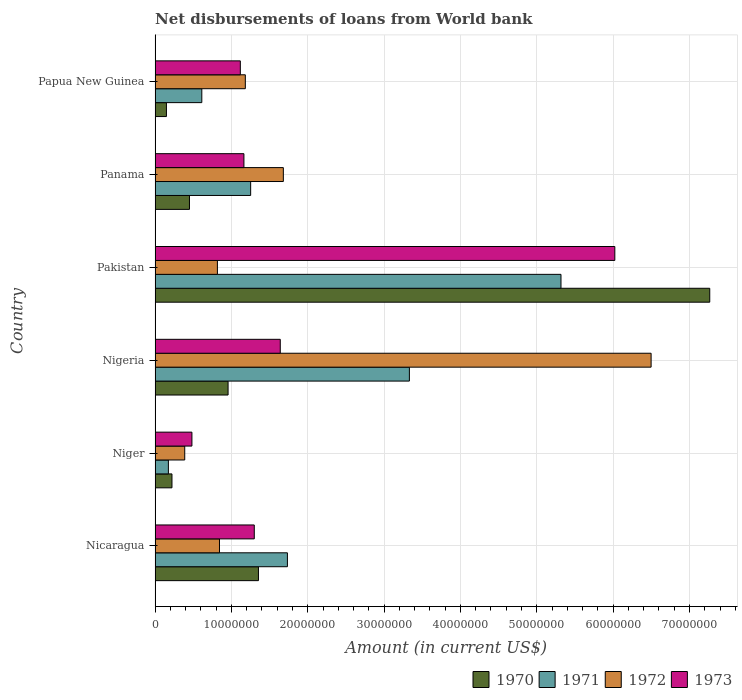How many different coloured bars are there?
Give a very brief answer. 4. How many groups of bars are there?
Provide a succinct answer. 6. Are the number of bars on each tick of the Y-axis equal?
Make the answer very short. Yes. How many bars are there on the 1st tick from the top?
Offer a terse response. 4. What is the label of the 4th group of bars from the top?
Ensure brevity in your answer.  Nigeria. What is the amount of loan disbursed from World Bank in 1972 in Niger?
Ensure brevity in your answer.  3.89e+06. Across all countries, what is the maximum amount of loan disbursed from World Bank in 1973?
Ensure brevity in your answer.  6.02e+07. Across all countries, what is the minimum amount of loan disbursed from World Bank in 1972?
Give a very brief answer. 3.89e+06. In which country was the amount of loan disbursed from World Bank in 1970 maximum?
Your response must be concise. Pakistan. In which country was the amount of loan disbursed from World Bank in 1972 minimum?
Provide a short and direct response. Niger. What is the total amount of loan disbursed from World Bank in 1970 in the graph?
Your answer should be compact. 1.04e+08. What is the difference between the amount of loan disbursed from World Bank in 1971 in Pakistan and that in Papua New Guinea?
Provide a succinct answer. 4.70e+07. What is the difference between the amount of loan disbursed from World Bank in 1971 in Papua New Guinea and the amount of loan disbursed from World Bank in 1972 in Niger?
Provide a succinct answer. 2.24e+06. What is the average amount of loan disbursed from World Bank in 1973 per country?
Your answer should be compact. 1.95e+07. What is the difference between the amount of loan disbursed from World Bank in 1970 and amount of loan disbursed from World Bank in 1971 in Nigeria?
Keep it short and to the point. -2.38e+07. What is the ratio of the amount of loan disbursed from World Bank in 1971 in Nicaragua to that in Niger?
Your response must be concise. 9.93. Is the amount of loan disbursed from World Bank in 1973 in Pakistan less than that in Papua New Guinea?
Make the answer very short. No. What is the difference between the highest and the second highest amount of loan disbursed from World Bank in 1972?
Your answer should be compact. 4.82e+07. What is the difference between the highest and the lowest amount of loan disbursed from World Bank in 1972?
Your answer should be very brief. 6.11e+07. Is the sum of the amount of loan disbursed from World Bank in 1971 in Nicaragua and Nigeria greater than the maximum amount of loan disbursed from World Bank in 1973 across all countries?
Give a very brief answer. No. What does the 2nd bar from the bottom in Nigeria represents?
Keep it short and to the point. 1971. Does the graph contain any zero values?
Give a very brief answer. No. Where does the legend appear in the graph?
Provide a short and direct response. Bottom right. How are the legend labels stacked?
Ensure brevity in your answer.  Horizontal. What is the title of the graph?
Provide a short and direct response. Net disbursements of loans from World bank. Does "1973" appear as one of the legend labels in the graph?
Provide a succinct answer. Yes. What is the label or title of the X-axis?
Give a very brief answer. Amount (in current US$). What is the label or title of the Y-axis?
Offer a terse response. Country. What is the Amount (in current US$) in 1970 in Nicaragua?
Your answer should be very brief. 1.35e+07. What is the Amount (in current US$) of 1971 in Nicaragua?
Ensure brevity in your answer.  1.73e+07. What is the Amount (in current US$) of 1972 in Nicaragua?
Keep it short and to the point. 8.44e+06. What is the Amount (in current US$) of 1973 in Nicaragua?
Offer a terse response. 1.30e+07. What is the Amount (in current US$) of 1970 in Niger?
Offer a very short reply. 2.22e+06. What is the Amount (in current US$) of 1971 in Niger?
Give a very brief answer. 1.75e+06. What is the Amount (in current US$) of 1972 in Niger?
Offer a very short reply. 3.89e+06. What is the Amount (in current US$) of 1973 in Niger?
Your response must be concise. 4.83e+06. What is the Amount (in current US$) of 1970 in Nigeria?
Ensure brevity in your answer.  9.56e+06. What is the Amount (in current US$) of 1971 in Nigeria?
Offer a very short reply. 3.33e+07. What is the Amount (in current US$) in 1972 in Nigeria?
Offer a very short reply. 6.50e+07. What is the Amount (in current US$) of 1973 in Nigeria?
Your answer should be compact. 1.64e+07. What is the Amount (in current US$) in 1970 in Pakistan?
Your answer should be very brief. 7.27e+07. What is the Amount (in current US$) in 1971 in Pakistan?
Keep it short and to the point. 5.32e+07. What is the Amount (in current US$) in 1972 in Pakistan?
Keep it short and to the point. 8.17e+06. What is the Amount (in current US$) in 1973 in Pakistan?
Make the answer very short. 6.02e+07. What is the Amount (in current US$) in 1970 in Panama?
Offer a very short reply. 4.51e+06. What is the Amount (in current US$) in 1971 in Panama?
Offer a terse response. 1.25e+07. What is the Amount (in current US$) of 1972 in Panama?
Ensure brevity in your answer.  1.68e+07. What is the Amount (in current US$) in 1973 in Panama?
Your answer should be compact. 1.16e+07. What is the Amount (in current US$) in 1970 in Papua New Guinea?
Ensure brevity in your answer.  1.49e+06. What is the Amount (in current US$) of 1971 in Papua New Guinea?
Offer a very short reply. 6.12e+06. What is the Amount (in current US$) in 1972 in Papua New Guinea?
Offer a very short reply. 1.18e+07. What is the Amount (in current US$) in 1973 in Papua New Guinea?
Your response must be concise. 1.12e+07. Across all countries, what is the maximum Amount (in current US$) of 1970?
Your response must be concise. 7.27e+07. Across all countries, what is the maximum Amount (in current US$) in 1971?
Give a very brief answer. 5.32e+07. Across all countries, what is the maximum Amount (in current US$) of 1972?
Make the answer very short. 6.50e+07. Across all countries, what is the maximum Amount (in current US$) in 1973?
Ensure brevity in your answer.  6.02e+07. Across all countries, what is the minimum Amount (in current US$) in 1970?
Give a very brief answer. 1.49e+06. Across all countries, what is the minimum Amount (in current US$) in 1971?
Offer a very short reply. 1.75e+06. Across all countries, what is the minimum Amount (in current US$) of 1972?
Make the answer very short. 3.89e+06. Across all countries, what is the minimum Amount (in current US$) of 1973?
Make the answer very short. 4.83e+06. What is the total Amount (in current US$) in 1970 in the graph?
Ensure brevity in your answer.  1.04e+08. What is the total Amount (in current US$) of 1971 in the graph?
Your response must be concise. 1.24e+08. What is the total Amount (in current US$) in 1972 in the graph?
Provide a short and direct response. 1.14e+08. What is the total Amount (in current US$) of 1973 in the graph?
Make the answer very short. 1.17e+08. What is the difference between the Amount (in current US$) in 1970 in Nicaragua and that in Niger?
Keep it short and to the point. 1.13e+07. What is the difference between the Amount (in current US$) in 1971 in Nicaragua and that in Niger?
Ensure brevity in your answer.  1.56e+07. What is the difference between the Amount (in current US$) in 1972 in Nicaragua and that in Niger?
Give a very brief answer. 4.55e+06. What is the difference between the Amount (in current US$) in 1973 in Nicaragua and that in Niger?
Provide a succinct answer. 8.17e+06. What is the difference between the Amount (in current US$) in 1970 in Nicaragua and that in Nigeria?
Your response must be concise. 3.98e+06. What is the difference between the Amount (in current US$) in 1971 in Nicaragua and that in Nigeria?
Provide a succinct answer. -1.60e+07. What is the difference between the Amount (in current US$) of 1972 in Nicaragua and that in Nigeria?
Keep it short and to the point. -5.65e+07. What is the difference between the Amount (in current US$) of 1973 in Nicaragua and that in Nigeria?
Offer a very short reply. -3.40e+06. What is the difference between the Amount (in current US$) in 1970 in Nicaragua and that in Pakistan?
Your answer should be compact. -5.91e+07. What is the difference between the Amount (in current US$) of 1971 in Nicaragua and that in Pakistan?
Ensure brevity in your answer.  -3.58e+07. What is the difference between the Amount (in current US$) of 1972 in Nicaragua and that in Pakistan?
Give a very brief answer. 2.72e+05. What is the difference between the Amount (in current US$) of 1973 in Nicaragua and that in Pakistan?
Provide a short and direct response. -4.72e+07. What is the difference between the Amount (in current US$) in 1970 in Nicaragua and that in Panama?
Your answer should be very brief. 9.03e+06. What is the difference between the Amount (in current US$) in 1971 in Nicaragua and that in Panama?
Offer a terse response. 4.82e+06. What is the difference between the Amount (in current US$) in 1972 in Nicaragua and that in Panama?
Offer a very short reply. -8.37e+06. What is the difference between the Amount (in current US$) in 1973 in Nicaragua and that in Panama?
Give a very brief answer. 1.36e+06. What is the difference between the Amount (in current US$) of 1970 in Nicaragua and that in Papua New Guinea?
Provide a succinct answer. 1.21e+07. What is the difference between the Amount (in current US$) of 1971 in Nicaragua and that in Papua New Guinea?
Your response must be concise. 1.12e+07. What is the difference between the Amount (in current US$) of 1972 in Nicaragua and that in Papua New Guinea?
Make the answer very short. -3.38e+06. What is the difference between the Amount (in current US$) of 1973 in Nicaragua and that in Papua New Guinea?
Your answer should be very brief. 1.83e+06. What is the difference between the Amount (in current US$) of 1970 in Niger and that in Nigeria?
Provide a succinct answer. -7.35e+06. What is the difference between the Amount (in current US$) of 1971 in Niger and that in Nigeria?
Your response must be concise. -3.16e+07. What is the difference between the Amount (in current US$) of 1972 in Niger and that in Nigeria?
Your answer should be very brief. -6.11e+07. What is the difference between the Amount (in current US$) in 1973 in Niger and that in Nigeria?
Offer a terse response. -1.16e+07. What is the difference between the Amount (in current US$) of 1970 in Niger and that in Pakistan?
Offer a terse response. -7.04e+07. What is the difference between the Amount (in current US$) of 1971 in Niger and that in Pakistan?
Offer a very short reply. -5.14e+07. What is the difference between the Amount (in current US$) in 1972 in Niger and that in Pakistan?
Your answer should be compact. -4.28e+06. What is the difference between the Amount (in current US$) of 1973 in Niger and that in Pakistan?
Your answer should be compact. -5.54e+07. What is the difference between the Amount (in current US$) of 1970 in Niger and that in Panama?
Your response must be concise. -2.29e+06. What is the difference between the Amount (in current US$) in 1971 in Niger and that in Panama?
Your answer should be compact. -1.08e+07. What is the difference between the Amount (in current US$) in 1972 in Niger and that in Panama?
Make the answer very short. -1.29e+07. What is the difference between the Amount (in current US$) of 1973 in Niger and that in Panama?
Provide a succinct answer. -6.81e+06. What is the difference between the Amount (in current US$) in 1970 in Niger and that in Papua New Guinea?
Provide a short and direct response. 7.25e+05. What is the difference between the Amount (in current US$) of 1971 in Niger and that in Papua New Guinea?
Keep it short and to the point. -4.38e+06. What is the difference between the Amount (in current US$) in 1972 in Niger and that in Papua New Guinea?
Ensure brevity in your answer.  -7.94e+06. What is the difference between the Amount (in current US$) in 1973 in Niger and that in Papua New Guinea?
Offer a terse response. -6.34e+06. What is the difference between the Amount (in current US$) of 1970 in Nigeria and that in Pakistan?
Your response must be concise. -6.31e+07. What is the difference between the Amount (in current US$) in 1971 in Nigeria and that in Pakistan?
Provide a succinct answer. -1.99e+07. What is the difference between the Amount (in current US$) in 1972 in Nigeria and that in Pakistan?
Offer a very short reply. 5.68e+07. What is the difference between the Amount (in current US$) of 1973 in Nigeria and that in Pakistan?
Your answer should be very brief. -4.38e+07. What is the difference between the Amount (in current US$) of 1970 in Nigeria and that in Panama?
Offer a very short reply. 5.06e+06. What is the difference between the Amount (in current US$) in 1971 in Nigeria and that in Panama?
Provide a succinct answer. 2.08e+07. What is the difference between the Amount (in current US$) in 1972 in Nigeria and that in Panama?
Provide a succinct answer. 4.82e+07. What is the difference between the Amount (in current US$) in 1973 in Nigeria and that in Panama?
Your answer should be compact. 4.76e+06. What is the difference between the Amount (in current US$) in 1970 in Nigeria and that in Papua New Guinea?
Offer a terse response. 8.07e+06. What is the difference between the Amount (in current US$) in 1971 in Nigeria and that in Papua New Guinea?
Keep it short and to the point. 2.72e+07. What is the difference between the Amount (in current US$) in 1972 in Nigeria and that in Papua New Guinea?
Make the answer very short. 5.32e+07. What is the difference between the Amount (in current US$) in 1973 in Nigeria and that in Papua New Guinea?
Give a very brief answer. 5.23e+06. What is the difference between the Amount (in current US$) of 1970 in Pakistan and that in Panama?
Provide a short and direct response. 6.81e+07. What is the difference between the Amount (in current US$) of 1971 in Pakistan and that in Panama?
Offer a terse response. 4.06e+07. What is the difference between the Amount (in current US$) in 1972 in Pakistan and that in Panama?
Provide a succinct answer. -8.64e+06. What is the difference between the Amount (in current US$) in 1973 in Pakistan and that in Panama?
Offer a terse response. 4.86e+07. What is the difference between the Amount (in current US$) of 1970 in Pakistan and that in Papua New Guinea?
Provide a short and direct response. 7.12e+07. What is the difference between the Amount (in current US$) of 1971 in Pakistan and that in Papua New Guinea?
Ensure brevity in your answer.  4.70e+07. What is the difference between the Amount (in current US$) in 1972 in Pakistan and that in Papua New Guinea?
Offer a very short reply. -3.66e+06. What is the difference between the Amount (in current US$) of 1973 in Pakistan and that in Papua New Guinea?
Your answer should be compact. 4.91e+07. What is the difference between the Amount (in current US$) of 1970 in Panama and that in Papua New Guinea?
Your response must be concise. 3.02e+06. What is the difference between the Amount (in current US$) of 1971 in Panama and that in Papua New Guinea?
Provide a short and direct response. 6.40e+06. What is the difference between the Amount (in current US$) in 1972 in Panama and that in Papua New Guinea?
Provide a succinct answer. 4.98e+06. What is the difference between the Amount (in current US$) of 1973 in Panama and that in Papua New Guinea?
Ensure brevity in your answer.  4.71e+05. What is the difference between the Amount (in current US$) in 1970 in Nicaragua and the Amount (in current US$) in 1971 in Niger?
Ensure brevity in your answer.  1.18e+07. What is the difference between the Amount (in current US$) in 1970 in Nicaragua and the Amount (in current US$) in 1972 in Niger?
Give a very brief answer. 9.66e+06. What is the difference between the Amount (in current US$) in 1970 in Nicaragua and the Amount (in current US$) in 1973 in Niger?
Ensure brevity in your answer.  8.71e+06. What is the difference between the Amount (in current US$) of 1971 in Nicaragua and the Amount (in current US$) of 1972 in Niger?
Your answer should be very brief. 1.35e+07. What is the difference between the Amount (in current US$) of 1971 in Nicaragua and the Amount (in current US$) of 1973 in Niger?
Your answer should be very brief. 1.25e+07. What is the difference between the Amount (in current US$) in 1972 in Nicaragua and the Amount (in current US$) in 1973 in Niger?
Your answer should be very brief. 3.61e+06. What is the difference between the Amount (in current US$) of 1970 in Nicaragua and the Amount (in current US$) of 1971 in Nigeria?
Your answer should be very brief. -1.98e+07. What is the difference between the Amount (in current US$) in 1970 in Nicaragua and the Amount (in current US$) in 1972 in Nigeria?
Offer a very short reply. -5.14e+07. What is the difference between the Amount (in current US$) of 1970 in Nicaragua and the Amount (in current US$) of 1973 in Nigeria?
Ensure brevity in your answer.  -2.86e+06. What is the difference between the Amount (in current US$) of 1971 in Nicaragua and the Amount (in current US$) of 1972 in Nigeria?
Provide a succinct answer. -4.76e+07. What is the difference between the Amount (in current US$) in 1971 in Nicaragua and the Amount (in current US$) in 1973 in Nigeria?
Offer a terse response. 9.37e+05. What is the difference between the Amount (in current US$) of 1972 in Nicaragua and the Amount (in current US$) of 1973 in Nigeria?
Your answer should be very brief. -7.96e+06. What is the difference between the Amount (in current US$) of 1970 in Nicaragua and the Amount (in current US$) of 1971 in Pakistan?
Provide a succinct answer. -3.96e+07. What is the difference between the Amount (in current US$) in 1970 in Nicaragua and the Amount (in current US$) in 1972 in Pakistan?
Provide a succinct answer. 5.38e+06. What is the difference between the Amount (in current US$) of 1970 in Nicaragua and the Amount (in current US$) of 1973 in Pakistan?
Keep it short and to the point. -4.67e+07. What is the difference between the Amount (in current US$) in 1971 in Nicaragua and the Amount (in current US$) in 1972 in Pakistan?
Keep it short and to the point. 9.17e+06. What is the difference between the Amount (in current US$) of 1971 in Nicaragua and the Amount (in current US$) of 1973 in Pakistan?
Your response must be concise. -4.29e+07. What is the difference between the Amount (in current US$) in 1972 in Nicaragua and the Amount (in current US$) in 1973 in Pakistan?
Keep it short and to the point. -5.18e+07. What is the difference between the Amount (in current US$) of 1970 in Nicaragua and the Amount (in current US$) of 1971 in Panama?
Offer a terse response. 1.02e+06. What is the difference between the Amount (in current US$) in 1970 in Nicaragua and the Amount (in current US$) in 1972 in Panama?
Make the answer very short. -3.26e+06. What is the difference between the Amount (in current US$) in 1970 in Nicaragua and the Amount (in current US$) in 1973 in Panama?
Make the answer very short. 1.90e+06. What is the difference between the Amount (in current US$) in 1971 in Nicaragua and the Amount (in current US$) in 1972 in Panama?
Give a very brief answer. 5.33e+05. What is the difference between the Amount (in current US$) in 1971 in Nicaragua and the Amount (in current US$) in 1973 in Panama?
Keep it short and to the point. 5.70e+06. What is the difference between the Amount (in current US$) of 1972 in Nicaragua and the Amount (in current US$) of 1973 in Panama?
Offer a terse response. -3.20e+06. What is the difference between the Amount (in current US$) of 1970 in Nicaragua and the Amount (in current US$) of 1971 in Papua New Guinea?
Keep it short and to the point. 7.42e+06. What is the difference between the Amount (in current US$) in 1970 in Nicaragua and the Amount (in current US$) in 1972 in Papua New Guinea?
Your answer should be very brief. 1.72e+06. What is the difference between the Amount (in current US$) of 1970 in Nicaragua and the Amount (in current US$) of 1973 in Papua New Guinea?
Your answer should be very brief. 2.37e+06. What is the difference between the Amount (in current US$) in 1971 in Nicaragua and the Amount (in current US$) in 1972 in Papua New Guinea?
Ensure brevity in your answer.  5.51e+06. What is the difference between the Amount (in current US$) of 1971 in Nicaragua and the Amount (in current US$) of 1973 in Papua New Guinea?
Offer a terse response. 6.17e+06. What is the difference between the Amount (in current US$) in 1972 in Nicaragua and the Amount (in current US$) in 1973 in Papua New Guinea?
Your answer should be compact. -2.73e+06. What is the difference between the Amount (in current US$) of 1970 in Niger and the Amount (in current US$) of 1971 in Nigeria?
Offer a terse response. -3.11e+07. What is the difference between the Amount (in current US$) in 1970 in Niger and the Amount (in current US$) in 1972 in Nigeria?
Offer a very short reply. -6.28e+07. What is the difference between the Amount (in current US$) in 1970 in Niger and the Amount (in current US$) in 1973 in Nigeria?
Offer a terse response. -1.42e+07. What is the difference between the Amount (in current US$) of 1971 in Niger and the Amount (in current US$) of 1972 in Nigeria?
Provide a short and direct response. -6.32e+07. What is the difference between the Amount (in current US$) of 1971 in Niger and the Amount (in current US$) of 1973 in Nigeria?
Give a very brief answer. -1.47e+07. What is the difference between the Amount (in current US$) in 1972 in Niger and the Amount (in current US$) in 1973 in Nigeria?
Your answer should be very brief. -1.25e+07. What is the difference between the Amount (in current US$) in 1970 in Niger and the Amount (in current US$) in 1971 in Pakistan?
Provide a succinct answer. -5.10e+07. What is the difference between the Amount (in current US$) of 1970 in Niger and the Amount (in current US$) of 1972 in Pakistan?
Give a very brief answer. -5.95e+06. What is the difference between the Amount (in current US$) of 1970 in Niger and the Amount (in current US$) of 1973 in Pakistan?
Give a very brief answer. -5.80e+07. What is the difference between the Amount (in current US$) in 1971 in Niger and the Amount (in current US$) in 1972 in Pakistan?
Your response must be concise. -6.42e+06. What is the difference between the Amount (in current US$) in 1971 in Niger and the Amount (in current US$) in 1973 in Pakistan?
Your response must be concise. -5.85e+07. What is the difference between the Amount (in current US$) of 1972 in Niger and the Amount (in current US$) of 1973 in Pakistan?
Offer a terse response. -5.63e+07. What is the difference between the Amount (in current US$) of 1970 in Niger and the Amount (in current US$) of 1971 in Panama?
Provide a short and direct response. -1.03e+07. What is the difference between the Amount (in current US$) in 1970 in Niger and the Amount (in current US$) in 1972 in Panama?
Your answer should be very brief. -1.46e+07. What is the difference between the Amount (in current US$) of 1970 in Niger and the Amount (in current US$) of 1973 in Panama?
Give a very brief answer. -9.42e+06. What is the difference between the Amount (in current US$) of 1971 in Niger and the Amount (in current US$) of 1972 in Panama?
Provide a short and direct response. -1.51e+07. What is the difference between the Amount (in current US$) of 1971 in Niger and the Amount (in current US$) of 1973 in Panama?
Provide a short and direct response. -9.89e+06. What is the difference between the Amount (in current US$) of 1972 in Niger and the Amount (in current US$) of 1973 in Panama?
Your answer should be compact. -7.75e+06. What is the difference between the Amount (in current US$) in 1970 in Niger and the Amount (in current US$) in 1971 in Papua New Guinea?
Offer a terse response. -3.91e+06. What is the difference between the Amount (in current US$) of 1970 in Niger and the Amount (in current US$) of 1972 in Papua New Guinea?
Provide a succinct answer. -9.61e+06. What is the difference between the Amount (in current US$) in 1970 in Niger and the Amount (in current US$) in 1973 in Papua New Guinea?
Your answer should be very brief. -8.95e+06. What is the difference between the Amount (in current US$) of 1971 in Niger and the Amount (in current US$) of 1972 in Papua New Guinea?
Your answer should be compact. -1.01e+07. What is the difference between the Amount (in current US$) in 1971 in Niger and the Amount (in current US$) in 1973 in Papua New Guinea?
Ensure brevity in your answer.  -9.42e+06. What is the difference between the Amount (in current US$) of 1972 in Niger and the Amount (in current US$) of 1973 in Papua New Guinea?
Provide a short and direct response. -7.28e+06. What is the difference between the Amount (in current US$) in 1970 in Nigeria and the Amount (in current US$) in 1971 in Pakistan?
Give a very brief answer. -4.36e+07. What is the difference between the Amount (in current US$) in 1970 in Nigeria and the Amount (in current US$) in 1972 in Pakistan?
Provide a short and direct response. 1.40e+06. What is the difference between the Amount (in current US$) of 1970 in Nigeria and the Amount (in current US$) of 1973 in Pakistan?
Your answer should be very brief. -5.07e+07. What is the difference between the Amount (in current US$) in 1971 in Nigeria and the Amount (in current US$) in 1972 in Pakistan?
Keep it short and to the point. 2.51e+07. What is the difference between the Amount (in current US$) in 1971 in Nigeria and the Amount (in current US$) in 1973 in Pakistan?
Your response must be concise. -2.69e+07. What is the difference between the Amount (in current US$) of 1972 in Nigeria and the Amount (in current US$) of 1973 in Pakistan?
Make the answer very short. 4.75e+06. What is the difference between the Amount (in current US$) in 1970 in Nigeria and the Amount (in current US$) in 1971 in Panama?
Offer a terse response. -2.96e+06. What is the difference between the Amount (in current US$) in 1970 in Nigeria and the Amount (in current US$) in 1972 in Panama?
Keep it short and to the point. -7.24e+06. What is the difference between the Amount (in current US$) of 1970 in Nigeria and the Amount (in current US$) of 1973 in Panama?
Ensure brevity in your answer.  -2.08e+06. What is the difference between the Amount (in current US$) of 1971 in Nigeria and the Amount (in current US$) of 1972 in Panama?
Ensure brevity in your answer.  1.65e+07. What is the difference between the Amount (in current US$) in 1971 in Nigeria and the Amount (in current US$) in 1973 in Panama?
Keep it short and to the point. 2.17e+07. What is the difference between the Amount (in current US$) in 1972 in Nigeria and the Amount (in current US$) in 1973 in Panama?
Your answer should be very brief. 5.33e+07. What is the difference between the Amount (in current US$) of 1970 in Nigeria and the Amount (in current US$) of 1971 in Papua New Guinea?
Offer a very short reply. 3.44e+06. What is the difference between the Amount (in current US$) in 1970 in Nigeria and the Amount (in current US$) in 1972 in Papua New Guinea?
Provide a succinct answer. -2.26e+06. What is the difference between the Amount (in current US$) in 1970 in Nigeria and the Amount (in current US$) in 1973 in Papua New Guinea?
Your answer should be very brief. -1.60e+06. What is the difference between the Amount (in current US$) of 1971 in Nigeria and the Amount (in current US$) of 1972 in Papua New Guinea?
Give a very brief answer. 2.15e+07. What is the difference between the Amount (in current US$) of 1971 in Nigeria and the Amount (in current US$) of 1973 in Papua New Guinea?
Your response must be concise. 2.21e+07. What is the difference between the Amount (in current US$) in 1972 in Nigeria and the Amount (in current US$) in 1973 in Papua New Guinea?
Give a very brief answer. 5.38e+07. What is the difference between the Amount (in current US$) in 1970 in Pakistan and the Amount (in current US$) in 1971 in Panama?
Your answer should be very brief. 6.01e+07. What is the difference between the Amount (in current US$) in 1970 in Pakistan and the Amount (in current US$) in 1972 in Panama?
Offer a terse response. 5.59e+07. What is the difference between the Amount (in current US$) of 1970 in Pakistan and the Amount (in current US$) of 1973 in Panama?
Your answer should be compact. 6.10e+07. What is the difference between the Amount (in current US$) of 1971 in Pakistan and the Amount (in current US$) of 1972 in Panama?
Make the answer very short. 3.64e+07. What is the difference between the Amount (in current US$) of 1971 in Pakistan and the Amount (in current US$) of 1973 in Panama?
Your answer should be compact. 4.15e+07. What is the difference between the Amount (in current US$) of 1972 in Pakistan and the Amount (in current US$) of 1973 in Panama?
Offer a very short reply. -3.47e+06. What is the difference between the Amount (in current US$) of 1970 in Pakistan and the Amount (in current US$) of 1971 in Papua New Guinea?
Your answer should be compact. 6.65e+07. What is the difference between the Amount (in current US$) of 1970 in Pakistan and the Amount (in current US$) of 1972 in Papua New Guinea?
Provide a short and direct response. 6.08e+07. What is the difference between the Amount (in current US$) of 1970 in Pakistan and the Amount (in current US$) of 1973 in Papua New Guinea?
Your answer should be very brief. 6.15e+07. What is the difference between the Amount (in current US$) of 1971 in Pakistan and the Amount (in current US$) of 1972 in Papua New Guinea?
Make the answer very short. 4.13e+07. What is the difference between the Amount (in current US$) in 1971 in Pakistan and the Amount (in current US$) in 1973 in Papua New Guinea?
Provide a short and direct response. 4.20e+07. What is the difference between the Amount (in current US$) of 1972 in Pakistan and the Amount (in current US$) of 1973 in Papua New Guinea?
Provide a short and direct response. -3.00e+06. What is the difference between the Amount (in current US$) of 1970 in Panama and the Amount (in current US$) of 1971 in Papua New Guinea?
Offer a terse response. -1.62e+06. What is the difference between the Amount (in current US$) in 1970 in Panama and the Amount (in current US$) in 1972 in Papua New Guinea?
Your answer should be compact. -7.32e+06. What is the difference between the Amount (in current US$) in 1970 in Panama and the Amount (in current US$) in 1973 in Papua New Guinea?
Provide a succinct answer. -6.66e+06. What is the difference between the Amount (in current US$) in 1971 in Panama and the Amount (in current US$) in 1972 in Papua New Guinea?
Offer a terse response. 6.99e+05. What is the difference between the Amount (in current US$) in 1971 in Panama and the Amount (in current US$) in 1973 in Papua New Guinea?
Keep it short and to the point. 1.35e+06. What is the difference between the Amount (in current US$) of 1972 in Panama and the Amount (in current US$) of 1973 in Papua New Guinea?
Make the answer very short. 5.64e+06. What is the average Amount (in current US$) of 1970 per country?
Offer a terse response. 1.73e+07. What is the average Amount (in current US$) in 1971 per country?
Ensure brevity in your answer.  2.07e+07. What is the average Amount (in current US$) of 1972 per country?
Offer a terse response. 1.90e+07. What is the average Amount (in current US$) in 1973 per country?
Your answer should be compact. 1.95e+07. What is the difference between the Amount (in current US$) of 1970 and Amount (in current US$) of 1971 in Nicaragua?
Your response must be concise. -3.80e+06. What is the difference between the Amount (in current US$) of 1970 and Amount (in current US$) of 1972 in Nicaragua?
Your response must be concise. 5.10e+06. What is the difference between the Amount (in current US$) of 1970 and Amount (in current US$) of 1973 in Nicaragua?
Provide a short and direct response. 5.46e+05. What is the difference between the Amount (in current US$) of 1971 and Amount (in current US$) of 1972 in Nicaragua?
Offer a terse response. 8.90e+06. What is the difference between the Amount (in current US$) of 1971 and Amount (in current US$) of 1973 in Nicaragua?
Your answer should be very brief. 4.34e+06. What is the difference between the Amount (in current US$) in 1972 and Amount (in current US$) in 1973 in Nicaragua?
Ensure brevity in your answer.  -4.56e+06. What is the difference between the Amount (in current US$) of 1970 and Amount (in current US$) of 1971 in Niger?
Your response must be concise. 4.69e+05. What is the difference between the Amount (in current US$) in 1970 and Amount (in current US$) in 1972 in Niger?
Make the answer very short. -1.67e+06. What is the difference between the Amount (in current US$) of 1970 and Amount (in current US$) of 1973 in Niger?
Ensure brevity in your answer.  -2.61e+06. What is the difference between the Amount (in current US$) of 1971 and Amount (in current US$) of 1972 in Niger?
Provide a succinct answer. -2.14e+06. What is the difference between the Amount (in current US$) of 1971 and Amount (in current US$) of 1973 in Niger?
Your answer should be very brief. -3.08e+06. What is the difference between the Amount (in current US$) in 1972 and Amount (in current US$) in 1973 in Niger?
Your answer should be very brief. -9.42e+05. What is the difference between the Amount (in current US$) in 1970 and Amount (in current US$) in 1971 in Nigeria?
Provide a succinct answer. -2.38e+07. What is the difference between the Amount (in current US$) of 1970 and Amount (in current US$) of 1972 in Nigeria?
Make the answer very short. -5.54e+07. What is the difference between the Amount (in current US$) in 1970 and Amount (in current US$) in 1973 in Nigeria?
Offer a very short reply. -6.84e+06. What is the difference between the Amount (in current US$) of 1971 and Amount (in current US$) of 1972 in Nigeria?
Your answer should be very brief. -3.17e+07. What is the difference between the Amount (in current US$) in 1971 and Amount (in current US$) in 1973 in Nigeria?
Provide a short and direct response. 1.69e+07. What is the difference between the Amount (in current US$) of 1972 and Amount (in current US$) of 1973 in Nigeria?
Keep it short and to the point. 4.86e+07. What is the difference between the Amount (in current US$) in 1970 and Amount (in current US$) in 1971 in Pakistan?
Your answer should be very brief. 1.95e+07. What is the difference between the Amount (in current US$) of 1970 and Amount (in current US$) of 1972 in Pakistan?
Your answer should be very brief. 6.45e+07. What is the difference between the Amount (in current US$) in 1970 and Amount (in current US$) in 1973 in Pakistan?
Offer a terse response. 1.24e+07. What is the difference between the Amount (in current US$) in 1971 and Amount (in current US$) in 1972 in Pakistan?
Offer a very short reply. 4.50e+07. What is the difference between the Amount (in current US$) of 1971 and Amount (in current US$) of 1973 in Pakistan?
Ensure brevity in your answer.  -7.05e+06. What is the difference between the Amount (in current US$) in 1972 and Amount (in current US$) in 1973 in Pakistan?
Provide a succinct answer. -5.21e+07. What is the difference between the Amount (in current US$) in 1970 and Amount (in current US$) in 1971 in Panama?
Your response must be concise. -8.01e+06. What is the difference between the Amount (in current US$) in 1970 and Amount (in current US$) in 1972 in Panama?
Ensure brevity in your answer.  -1.23e+07. What is the difference between the Amount (in current US$) in 1970 and Amount (in current US$) in 1973 in Panama?
Give a very brief answer. -7.13e+06. What is the difference between the Amount (in current US$) in 1971 and Amount (in current US$) in 1972 in Panama?
Offer a terse response. -4.28e+06. What is the difference between the Amount (in current US$) in 1971 and Amount (in current US$) in 1973 in Panama?
Your answer should be very brief. 8.82e+05. What is the difference between the Amount (in current US$) of 1972 and Amount (in current US$) of 1973 in Panama?
Provide a succinct answer. 5.16e+06. What is the difference between the Amount (in current US$) of 1970 and Amount (in current US$) of 1971 in Papua New Guinea?
Your answer should be compact. -4.63e+06. What is the difference between the Amount (in current US$) in 1970 and Amount (in current US$) in 1972 in Papua New Guinea?
Your answer should be compact. -1.03e+07. What is the difference between the Amount (in current US$) of 1970 and Amount (in current US$) of 1973 in Papua New Guinea?
Ensure brevity in your answer.  -9.68e+06. What is the difference between the Amount (in current US$) of 1971 and Amount (in current US$) of 1972 in Papua New Guinea?
Offer a very short reply. -5.70e+06. What is the difference between the Amount (in current US$) of 1971 and Amount (in current US$) of 1973 in Papua New Guinea?
Your response must be concise. -5.04e+06. What is the difference between the Amount (in current US$) in 1972 and Amount (in current US$) in 1973 in Papua New Guinea?
Make the answer very short. 6.54e+05. What is the ratio of the Amount (in current US$) in 1970 in Nicaragua to that in Niger?
Provide a succinct answer. 6.11. What is the ratio of the Amount (in current US$) of 1971 in Nicaragua to that in Niger?
Offer a very short reply. 9.93. What is the ratio of the Amount (in current US$) of 1972 in Nicaragua to that in Niger?
Keep it short and to the point. 2.17. What is the ratio of the Amount (in current US$) in 1973 in Nicaragua to that in Niger?
Provide a succinct answer. 2.69. What is the ratio of the Amount (in current US$) of 1970 in Nicaragua to that in Nigeria?
Give a very brief answer. 1.42. What is the ratio of the Amount (in current US$) in 1971 in Nicaragua to that in Nigeria?
Offer a terse response. 0.52. What is the ratio of the Amount (in current US$) in 1972 in Nicaragua to that in Nigeria?
Offer a very short reply. 0.13. What is the ratio of the Amount (in current US$) of 1973 in Nicaragua to that in Nigeria?
Your answer should be very brief. 0.79. What is the ratio of the Amount (in current US$) in 1970 in Nicaragua to that in Pakistan?
Make the answer very short. 0.19. What is the ratio of the Amount (in current US$) of 1971 in Nicaragua to that in Pakistan?
Offer a terse response. 0.33. What is the ratio of the Amount (in current US$) in 1972 in Nicaragua to that in Pakistan?
Give a very brief answer. 1.03. What is the ratio of the Amount (in current US$) of 1973 in Nicaragua to that in Pakistan?
Offer a very short reply. 0.22. What is the ratio of the Amount (in current US$) in 1970 in Nicaragua to that in Panama?
Your response must be concise. 3. What is the ratio of the Amount (in current US$) in 1971 in Nicaragua to that in Panama?
Make the answer very short. 1.38. What is the ratio of the Amount (in current US$) of 1972 in Nicaragua to that in Panama?
Provide a short and direct response. 0.5. What is the ratio of the Amount (in current US$) of 1973 in Nicaragua to that in Panama?
Your answer should be compact. 1.12. What is the ratio of the Amount (in current US$) of 1970 in Nicaragua to that in Papua New Guinea?
Offer a terse response. 9.09. What is the ratio of the Amount (in current US$) in 1971 in Nicaragua to that in Papua New Guinea?
Provide a succinct answer. 2.83. What is the ratio of the Amount (in current US$) of 1972 in Nicaragua to that in Papua New Guinea?
Provide a short and direct response. 0.71. What is the ratio of the Amount (in current US$) of 1973 in Nicaragua to that in Papua New Guinea?
Offer a terse response. 1.16. What is the ratio of the Amount (in current US$) in 1970 in Niger to that in Nigeria?
Your answer should be compact. 0.23. What is the ratio of the Amount (in current US$) of 1971 in Niger to that in Nigeria?
Keep it short and to the point. 0.05. What is the ratio of the Amount (in current US$) of 1972 in Niger to that in Nigeria?
Keep it short and to the point. 0.06. What is the ratio of the Amount (in current US$) in 1973 in Niger to that in Nigeria?
Your answer should be compact. 0.29. What is the ratio of the Amount (in current US$) in 1970 in Niger to that in Pakistan?
Your answer should be very brief. 0.03. What is the ratio of the Amount (in current US$) of 1971 in Niger to that in Pakistan?
Ensure brevity in your answer.  0.03. What is the ratio of the Amount (in current US$) in 1972 in Niger to that in Pakistan?
Your response must be concise. 0.48. What is the ratio of the Amount (in current US$) of 1973 in Niger to that in Pakistan?
Provide a short and direct response. 0.08. What is the ratio of the Amount (in current US$) in 1970 in Niger to that in Panama?
Your response must be concise. 0.49. What is the ratio of the Amount (in current US$) of 1971 in Niger to that in Panama?
Your answer should be very brief. 0.14. What is the ratio of the Amount (in current US$) of 1972 in Niger to that in Panama?
Make the answer very short. 0.23. What is the ratio of the Amount (in current US$) in 1973 in Niger to that in Panama?
Give a very brief answer. 0.41. What is the ratio of the Amount (in current US$) in 1970 in Niger to that in Papua New Guinea?
Make the answer very short. 1.49. What is the ratio of the Amount (in current US$) in 1971 in Niger to that in Papua New Guinea?
Ensure brevity in your answer.  0.29. What is the ratio of the Amount (in current US$) of 1972 in Niger to that in Papua New Guinea?
Your answer should be very brief. 0.33. What is the ratio of the Amount (in current US$) of 1973 in Niger to that in Papua New Guinea?
Offer a very short reply. 0.43. What is the ratio of the Amount (in current US$) in 1970 in Nigeria to that in Pakistan?
Provide a short and direct response. 0.13. What is the ratio of the Amount (in current US$) in 1971 in Nigeria to that in Pakistan?
Your answer should be very brief. 0.63. What is the ratio of the Amount (in current US$) in 1972 in Nigeria to that in Pakistan?
Offer a terse response. 7.96. What is the ratio of the Amount (in current US$) of 1973 in Nigeria to that in Pakistan?
Your answer should be very brief. 0.27. What is the ratio of the Amount (in current US$) in 1970 in Nigeria to that in Panama?
Offer a very short reply. 2.12. What is the ratio of the Amount (in current US$) in 1971 in Nigeria to that in Panama?
Ensure brevity in your answer.  2.66. What is the ratio of the Amount (in current US$) of 1972 in Nigeria to that in Panama?
Give a very brief answer. 3.87. What is the ratio of the Amount (in current US$) in 1973 in Nigeria to that in Panama?
Your answer should be very brief. 1.41. What is the ratio of the Amount (in current US$) of 1970 in Nigeria to that in Papua New Guinea?
Offer a very short reply. 6.42. What is the ratio of the Amount (in current US$) in 1971 in Nigeria to that in Papua New Guinea?
Your answer should be very brief. 5.44. What is the ratio of the Amount (in current US$) of 1972 in Nigeria to that in Papua New Guinea?
Offer a very short reply. 5.5. What is the ratio of the Amount (in current US$) in 1973 in Nigeria to that in Papua New Guinea?
Offer a terse response. 1.47. What is the ratio of the Amount (in current US$) of 1970 in Pakistan to that in Panama?
Provide a succinct answer. 16.12. What is the ratio of the Amount (in current US$) of 1971 in Pakistan to that in Panama?
Provide a short and direct response. 4.25. What is the ratio of the Amount (in current US$) in 1972 in Pakistan to that in Panama?
Your answer should be compact. 0.49. What is the ratio of the Amount (in current US$) of 1973 in Pakistan to that in Panama?
Make the answer very short. 5.17. What is the ratio of the Amount (in current US$) of 1970 in Pakistan to that in Papua New Guinea?
Provide a succinct answer. 48.76. What is the ratio of the Amount (in current US$) of 1971 in Pakistan to that in Papua New Guinea?
Provide a succinct answer. 8.68. What is the ratio of the Amount (in current US$) of 1972 in Pakistan to that in Papua New Guinea?
Your response must be concise. 0.69. What is the ratio of the Amount (in current US$) in 1973 in Pakistan to that in Papua New Guinea?
Provide a short and direct response. 5.39. What is the ratio of the Amount (in current US$) of 1970 in Panama to that in Papua New Guinea?
Provide a short and direct response. 3.03. What is the ratio of the Amount (in current US$) in 1971 in Panama to that in Papua New Guinea?
Your answer should be very brief. 2.04. What is the ratio of the Amount (in current US$) of 1972 in Panama to that in Papua New Guinea?
Offer a very short reply. 1.42. What is the ratio of the Amount (in current US$) of 1973 in Panama to that in Papua New Guinea?
Provide a short and direct response. 1.04. What is the difference between the highest and the second highest Amount (in current US$) in 1970?
Your answer should be compact. 5.91e+07. What is the difference between the highest and the second highest Amount (in current US$) in 1971?
Offer a very short reply. 1.99e+07. What is the difference between the highest and the second highest Amount (in current US$) of 1972?
Ensure brevity in your answer.  4.82e+07. What is the difference between the highest and the second highest Amount (in current US$) of 1973?
Ensure brevity in your answer.  4.38e+07. What is the difference between the highest and the lowest Amount (in current US$) in 1970?
Provide a succinct answer. 7.12e+07. What is the difference between the highest and the lowest Amount (in current US$) of 1971?
Keep it short and to the point. 5.14e+07. What is the difference between the highest and the lowest Amount (in current US$) in 1972?
Make the answer very short. 6.11e+07. What is the difference between the highest and the lowest Amount (in current US$) in 1973?
Your answer should be very brief. 5.54e+07. 